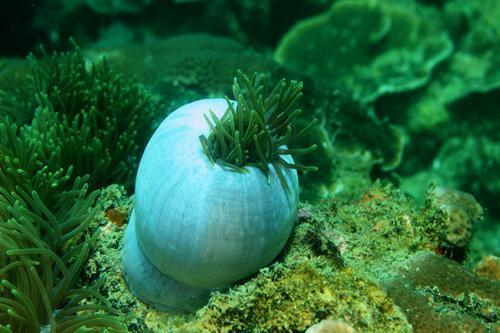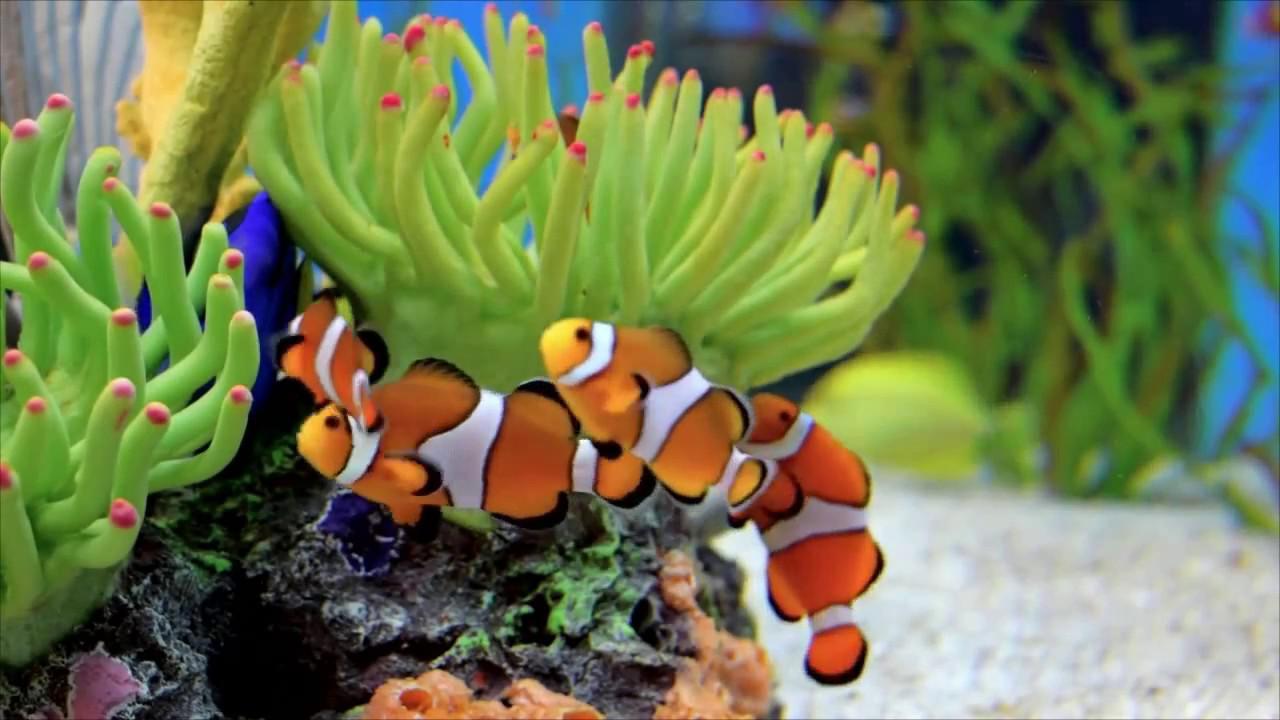The first image is the image on the left, the second image is the image on the right. Examine the images to the left and right. Is the description "The left image contains at least one clown fish with white stripes." accurate? Answer yes or no. No. The first image is the image on the left, the second image is the image on the right. Assess this claim about the two images: "In the right image, multiple clown fish with white stripes on bright orange are near flowing anemone tendrils with rounded tips.". Correct or not? Answer yes or no. Yes. 